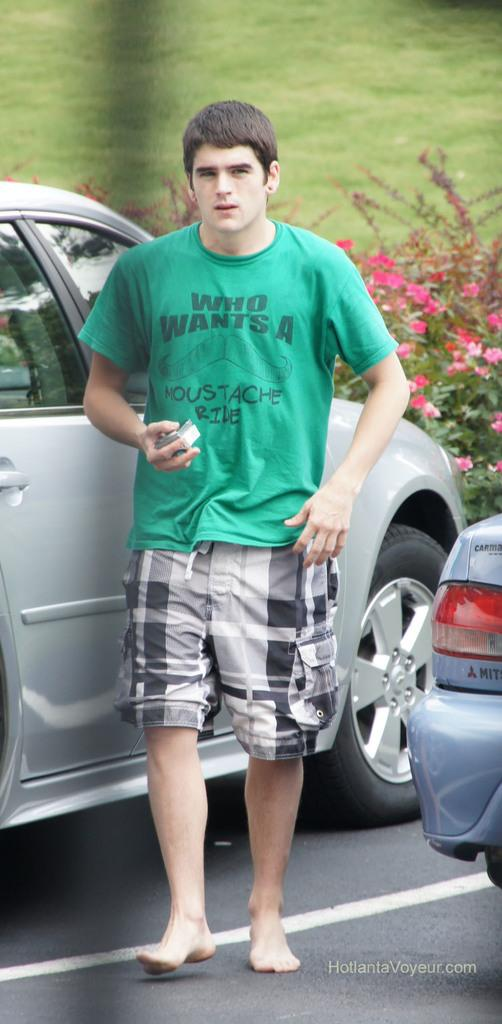What is the main subject of the image? The main subject of the image is a boy standing on the road. What else can be seen in the image besides the boy? There are cars in the image. What type of natural environment is visible in the background of the image? There is grass visible in the background of the image. What type of button is the boy wearing on his shirt in the image? There is no button visible on the boy's shirt in the image. What type of flooring can be seen in the image? The image does not show any flooring, as it is focused on the boy standing on the road and the surrounding environment. 